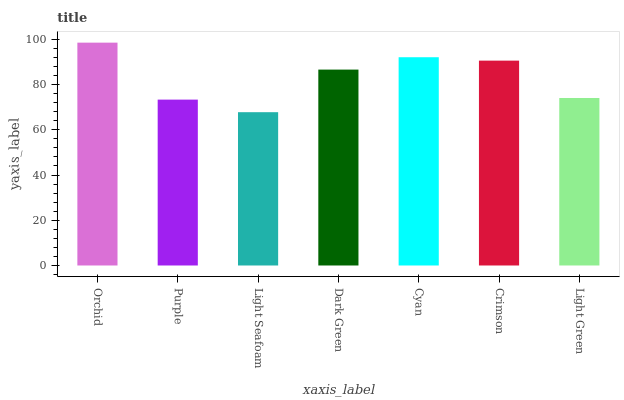Is Light Seafoam the minimum?
Answer yes or no. Yes. Is Orchid the maximum?
Answer yes or no. Yes. Is Purple the minimum?
Answer yes or no. No. Is Purple the maximum?
Answer yes or no. No. Is Orchid greater than Purple?
Answer yes or no. Yes. Is Purple less than Orchid?
Answer yes or no. Yes. Is Purple greater than Orchid?
Answer yes or no. No. Is Orchid less than Purple?
Answer yes or no. No. Is Dark Green the high median?
Answer yes or no. Yes. Is Dark Green the low median?
Answer yes or no. Yes. Is Light Seafoam the high median?
Answer yes or no. No. Is Crimson the low median?
Answer yes or no. No. 